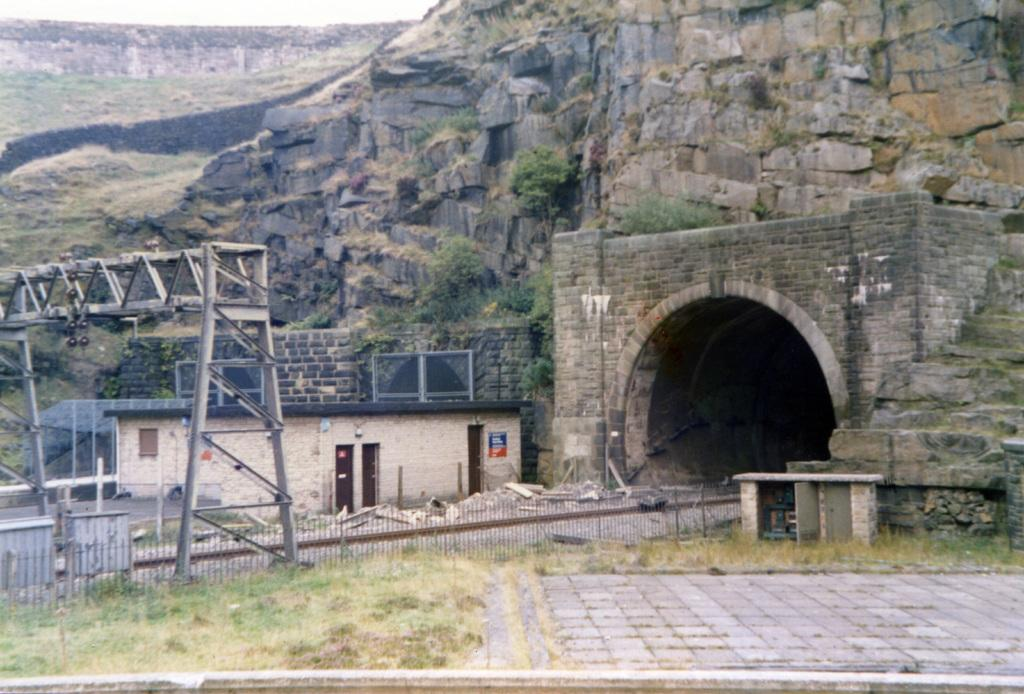What type of vegetation can be seen in the image? There is grass in the image. What structures are present in the image? There are fed poles and a building in the image. What architectural feature is visible in the image? There is a tunnel visible in the image. What type of salt can be seen on the fed poles in the image? There is no salt present on the fed poles in the image. What type of horn is visible on the building in the image? There is no horn visible on the building in the image. 